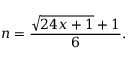<formula> <loc_0><loc_0><loc_500><loc_500>n = { \frac { { \sqrt { 2 4 x + 1 } } + 1 } { 6 } } .</formula> 